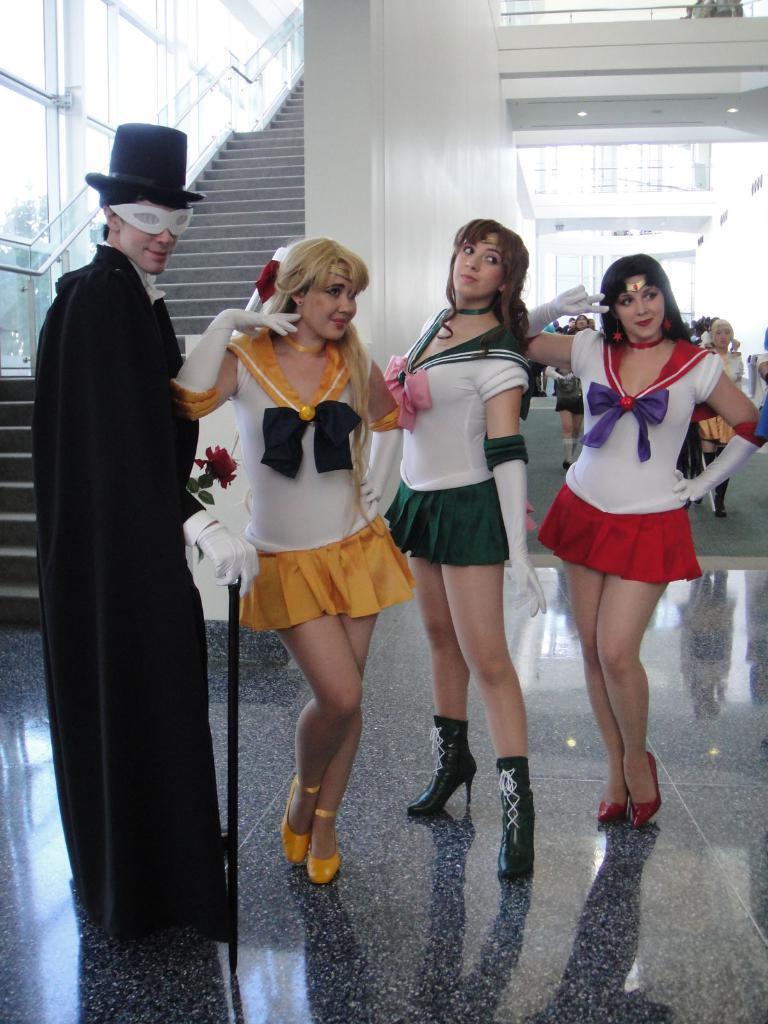In one or two sentences, can you explain what this image depicts? In this image we can see persons with costume. In the back we can see glass wall. Also there are steps. And there is another wall. And there are few people. 